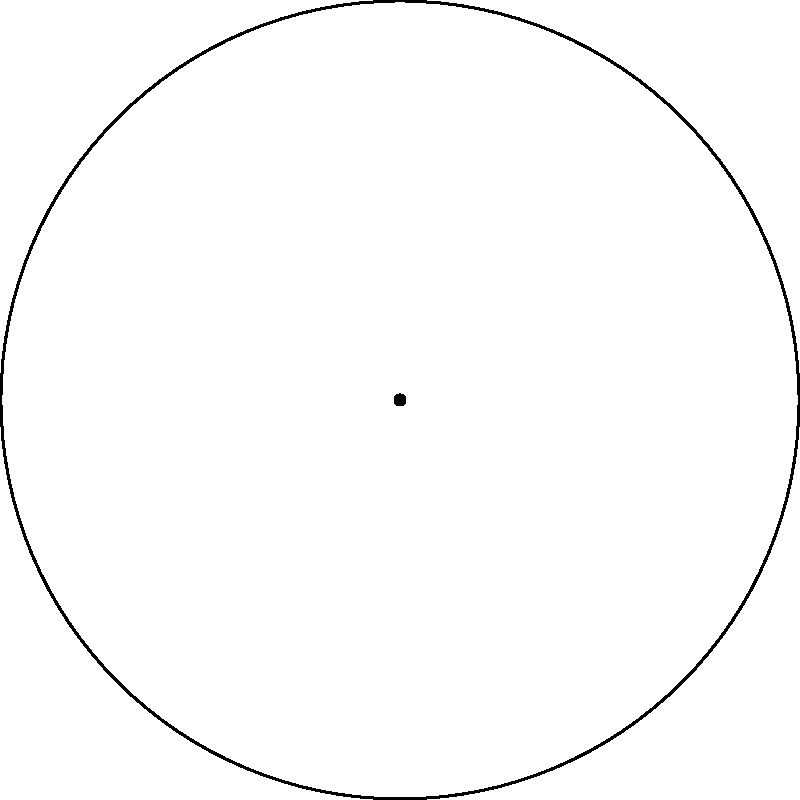At a Travis Tritt concert, the circular stage is set up with 6 equally spaced microphones, numbered 1 to 6 as shown in the diagram. The stage can rotate in multiples of 60°. How many unique arrangements of the microphones are possible through these rotations, and what is the order of the rotation group for this setup? Let's approach this step-by-step:

1) First, we need to understand what the rotation group is. In this case, it's the group of rotations that leave the arrangement of microphones looking the same.

2) The stage can rotate in multiples of 60°. Let's consider each rotation:
   - 0° (no rotation)
   - 60° clockwise
   - 120° clockwise
   - 180° clockwise
   - 240° clockwise
   - 300° clockwise

3) After a 360° rotation, we're back to the original position. So these are all the possible rotations.

4) Each of these rotations results in a different arrangement of the microphones:
   - 0°: 1-2-3-4-5-6
   - 60°: 6-1-2-3-4-5
   - 120°: 5-6-1-2-3-4
   - 180°: 4-5-6-1-2-3
   - 240°: 3-4-5-6-1-2
   - 300°: 2-3-4-5-6-1

5) We can see that there are 6 unique arrangements.

6) The order of a group is the number of elements in the group. Since we have 6 unique rotations (including the identity rotation of 0°), the order of this rotation group is 6.

7) In group theory, this is known as the cyclic group of order 6, often denoted as $C_6$ or $\mathbb{Z}_6$.
Answer: 6 unique arrangements; order of rotation group is 6 